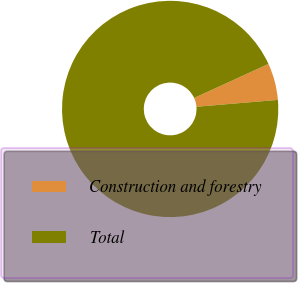Convert chart. <chart><loc_0><loc_0><loc_500><loc_500><pie_chart><fcel>Construction and forestry<fcel>Total<nl><fcel>5.5%<fcel>94.5%<nl></chart> 